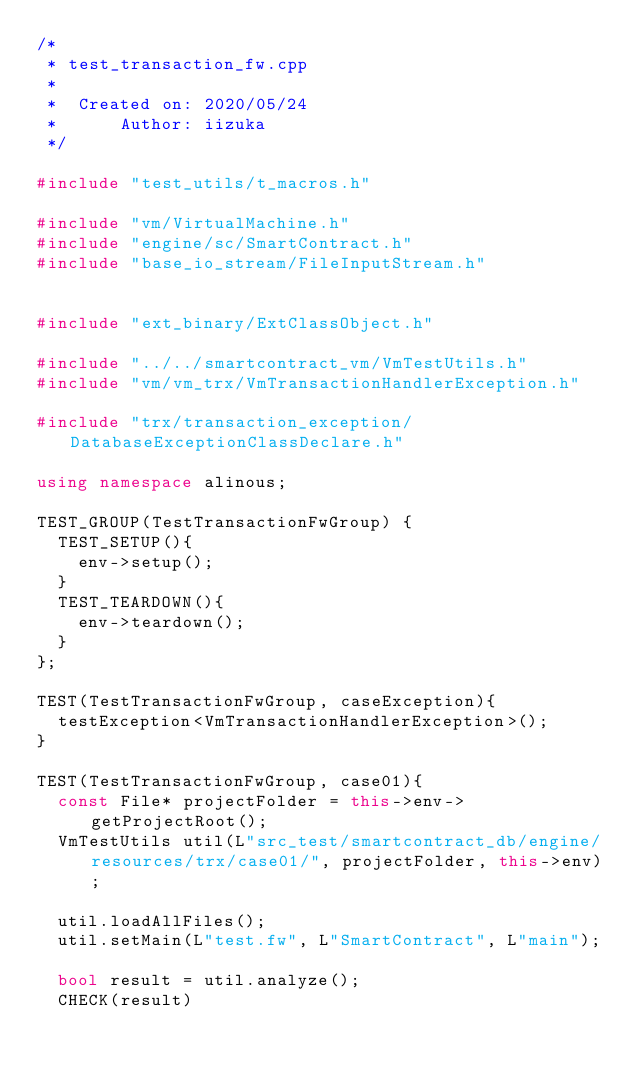Convert code to text. <code><loc_0><loc_0><loc_500><loc_500><_C++_>/*
 * test_transaction_fw.cpp
 *
 *  Created on: 2020/05/24
 *      Author: iizuka
 */

#include "test_utils/t_macros.h"

#include "vm/VirtualMachine.h"
#include "engine/sc/SmartContract.h"
#include "base_io_stream/FileInputStream.h"


#include "ext_binary/ExtClassObject.h"

#include "../../smartcontract_vm/VmTestUtils.h"
#include "vm/vm_trx/VmTransactionHandlerException.h"

#include "trx/transaction_exception/DatabaseExceptionClassDeclare.h"

using namespace alinous;

TEST_GROUP(TestTransactionFwGroup) {
	TEST_SETUP(){
		env->setup();
	}
	TEST_TEARDOWN(){
		env->teardown();
	}
};

TEST(TestTransactionFwGroup, caseException){
	testException<VmTransactionHandlerException>();
}

TEST(TestTransactionFwGroup, case01){
	const File* projectFolder = this->env->getProjectRoot();
	VmTestUtils util(L"src_test/smartcontract_db/engine/resources/trx/case01/", projectFolder, this->env);

	util.loadAllFiles();
	util.setMain(L"test.fw", L"SmartContract", L"main");

	bool result = util.analyze();
	CHECK(result)
</code> 